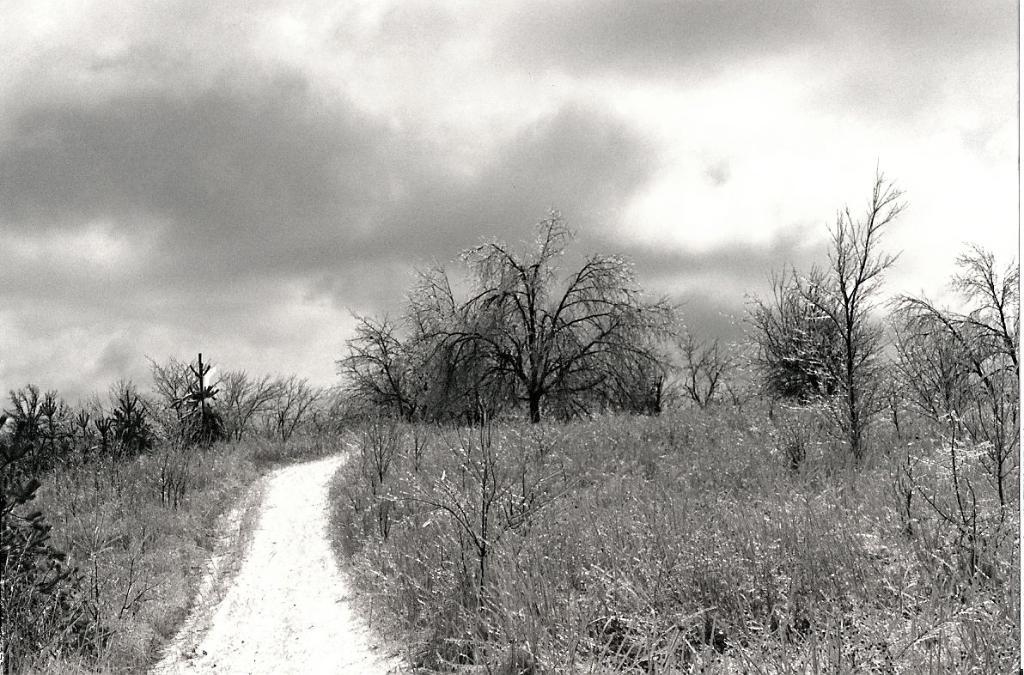What is the color scheme of the image? The image is black and white. What can be seen in the image besides the color scheme? There is a path, trees on both the right and left sides, grass, and the sky visible in the background. What type of nation is depicted in the image? There is no nation depicted in the image; it is a black and white scene featuring a path, trees, grass, and the sky. Can you tell me how many crates are present in the image? There are no crates present in the image. 